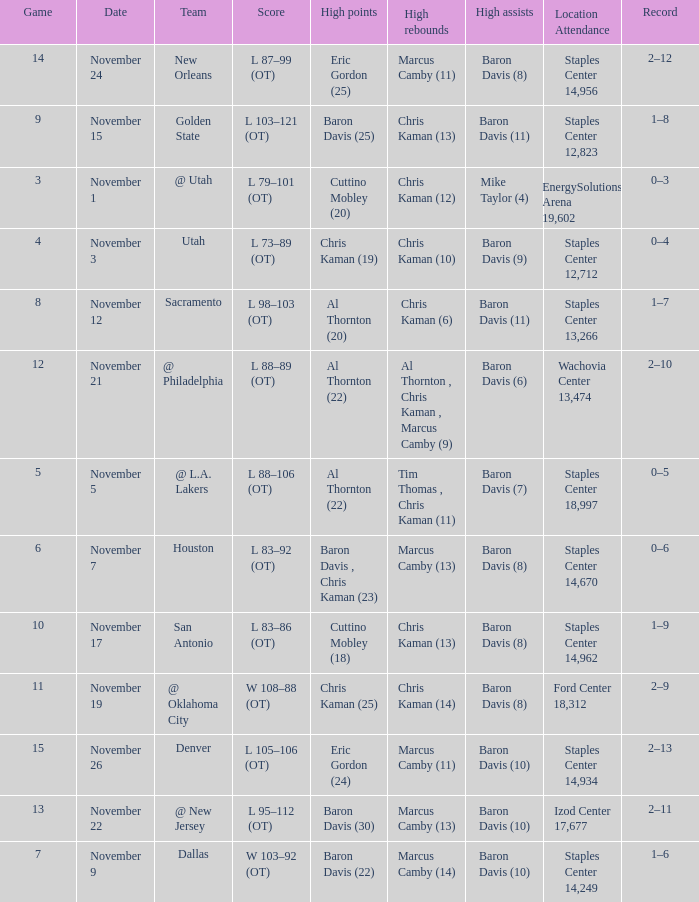Name the high points for the date of november 24 Eric Gordon (25). 